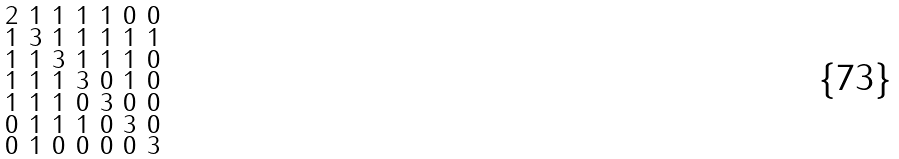Convert formula to latex. <formula><loc_0><loc_0><loc_500><loc_500>\begin{smallmatrix} 2 & 1 & 1 & 1 & 1 & 0 & 0 \\ 1 & 3 & 1 & 1 & 1 & 1 & 1 \\ 1 & 1 & 3 & 1 & 1 & 1 & 0 \\ 1 & 1 & 1 & 3 & 0 & 1 & 0 \\ 1 & 1 & 1 & 0 & 3 & 0 & 0 \\ 0 & 1 & 1 & 1 & 0 & 3 & 0 \\ 0 & 1 & 0 & 0 & 0 & 0 & 3 \end{smallmatrix}</formula> 